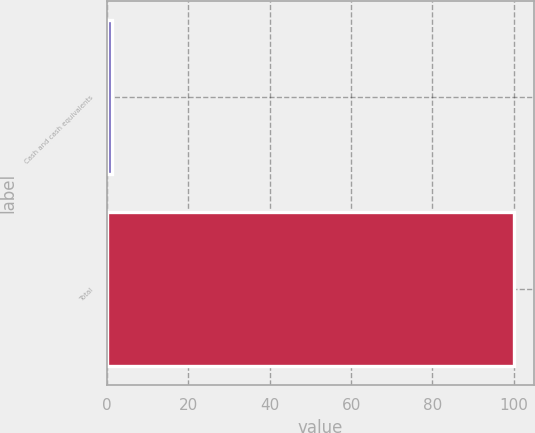<chart> <loc_0><loc_0><loc_500><loc_500><bar_chart><fcel>Cash and cash equivalents<fcel>Total<nl><fcel>1.2<fcel>100<nl></chart> 